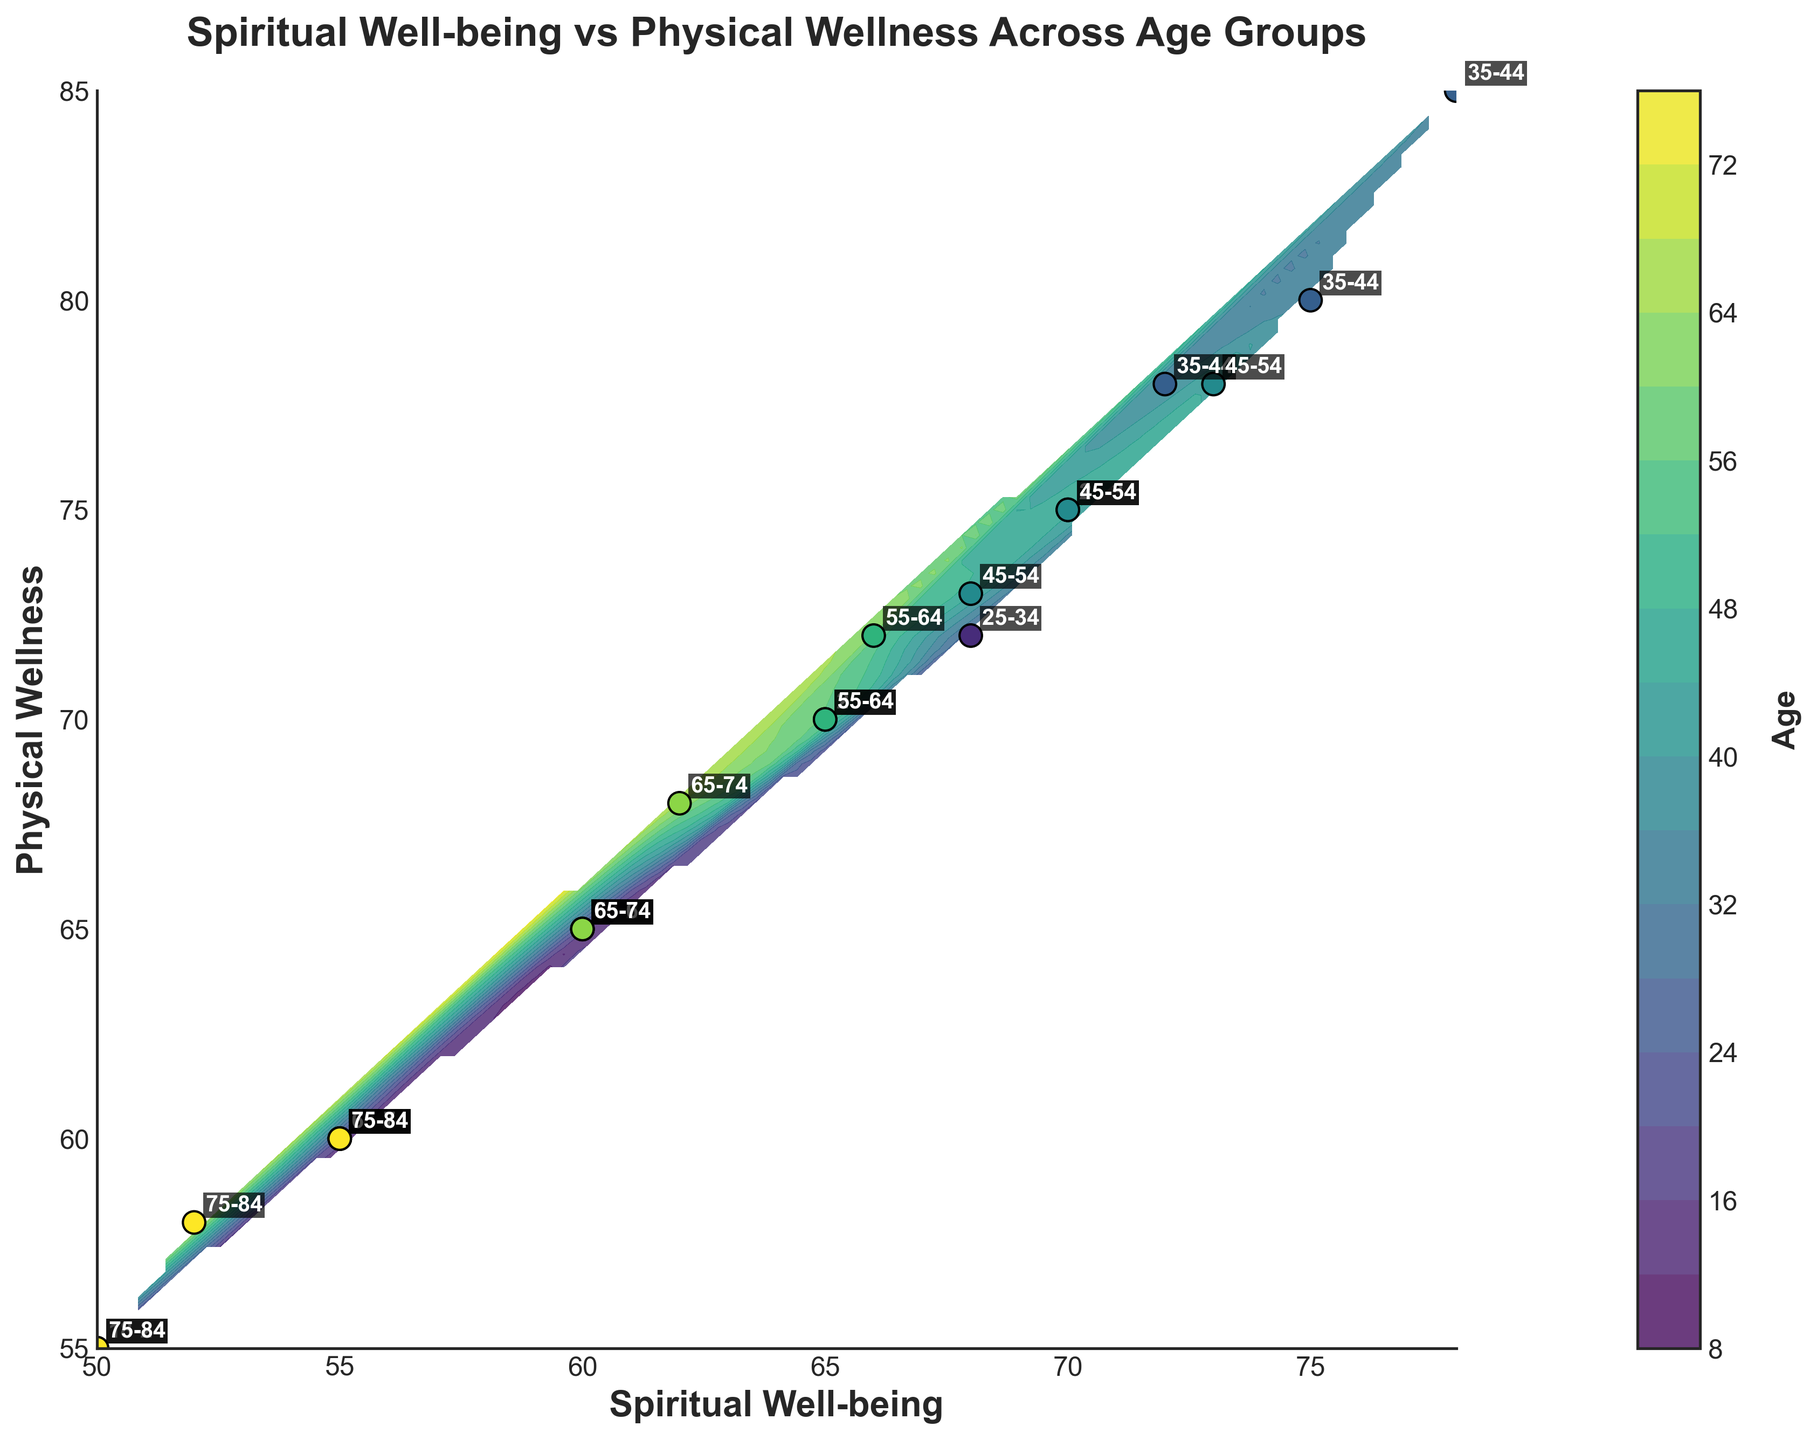What is the title of the plot? The title is usually displayed prominently at the top of the plot, indicating the content or main focus. Here, it reads "Spiritual Well-being vs Physical Wellness Across Age Groups."
Answer: Spiritual Well-being vs Physical Wellness Across Age Groups How many age groups are represented in the plot? By looking at the different labels annotated near the data points, one can count the distinct age groups. The labels show 18-24, 25-34, 35-44, 45-54, 55-64, 65-74, and 75-84.
Answer: 7 Which age group has the highest values of both spiritual well-being and physical wellness? The plot shows different age groups with corresponding values indicated by the labels. The age group with the highest values on both axes is "35-44".
Answer: 35-44 What is the average physical wellness of the 35-44 age group? The physical wellness values for the 35-44 age group are 80, 85, and 78. To find the average, sum these values and divide by the number of them: (80+85+78)/3. The average is (243/3)=81.
Answer: 81 Compare the physical wellness of the 18-24 age group and the 55-64 age group. Which one typically has higher values? We examine the data points for each age group. For 18-24, the values are 60, 65, and 55. For 55-64, the values are 70, 72, and 65. By averaging, 18-24 yields (60+65+55)/3 = 60 and 55-64 yields (70+72+65)/3 = 69. Thus, 55-64 has higher physical wellness values.
Answer: 55-64 Are there older age groups (65 and above) with spiritual well-being below 60? By scanning the contour plot where spiritual well-being is marked, we can see that the 65-74 and 75-84 age groups have data points below the value of 60.
Answer: Yes What is the most common (mode) age group in this data set? To determine the mode, look at the frequency of each age group's label. The 75-84 age group has three instances, which appears most frequently among all labels.
Answer: 75-84 Which age group shows a more significant spread in spiritual well-being data points? By observing the range of spiritual well-being values for each age group label, "25-34" spans from 65 to 70, thus covering a larger range (5 units) compared to others.
Answer: 25-34 How does the physical wellness of the 75-84 age group compare to younger groups like 18-24 and 25-34? We analyze the physical wellness values for the 75-84 group (60, 55, 58) and find its average is (60+55+58)/3 = 57.67. For 18-24, the average is 60; for 25-34, the values are 70, 75, and 72, averaging (70+75+72)/3=72. Thus, younger groups have higher physical wellness values.
Answer: Lower Which age group is closest to having balanced values of spiritual well-being and physical wellness? We look for age groups where the points lie on the diagonal or near (where spiritual well-being roughly equals physical wellness). The "45-54" age group has values around 70 to 75, indicating more balanced values compared to other groups.
Answer: 45-54 